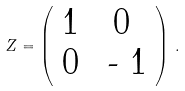Convert formula to latex. <formula><loc_0><loc_0><loc_500><loc_500>Z = \left ( \begin{array} { c c } 1 & 0 \\ 0 & $ - $ 1 \\ \end{array} \right ) \, .</formula> 